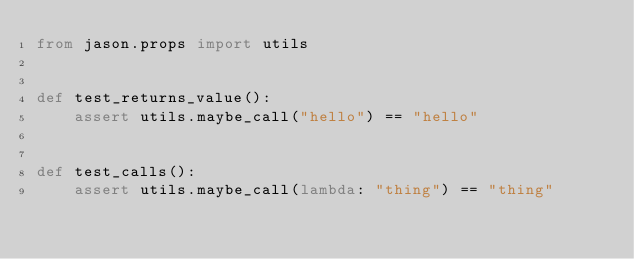Convert code to text. <code><loc_0><loc_0><loc_500><loc_500><_Python_>from jason.props import utils


def test_returns_value():
    assert utils.maybe_call("hello") == "hello"


def test_calls():
    assert utils.maybe_call(lambda: "thing") == "thing"
</code> 